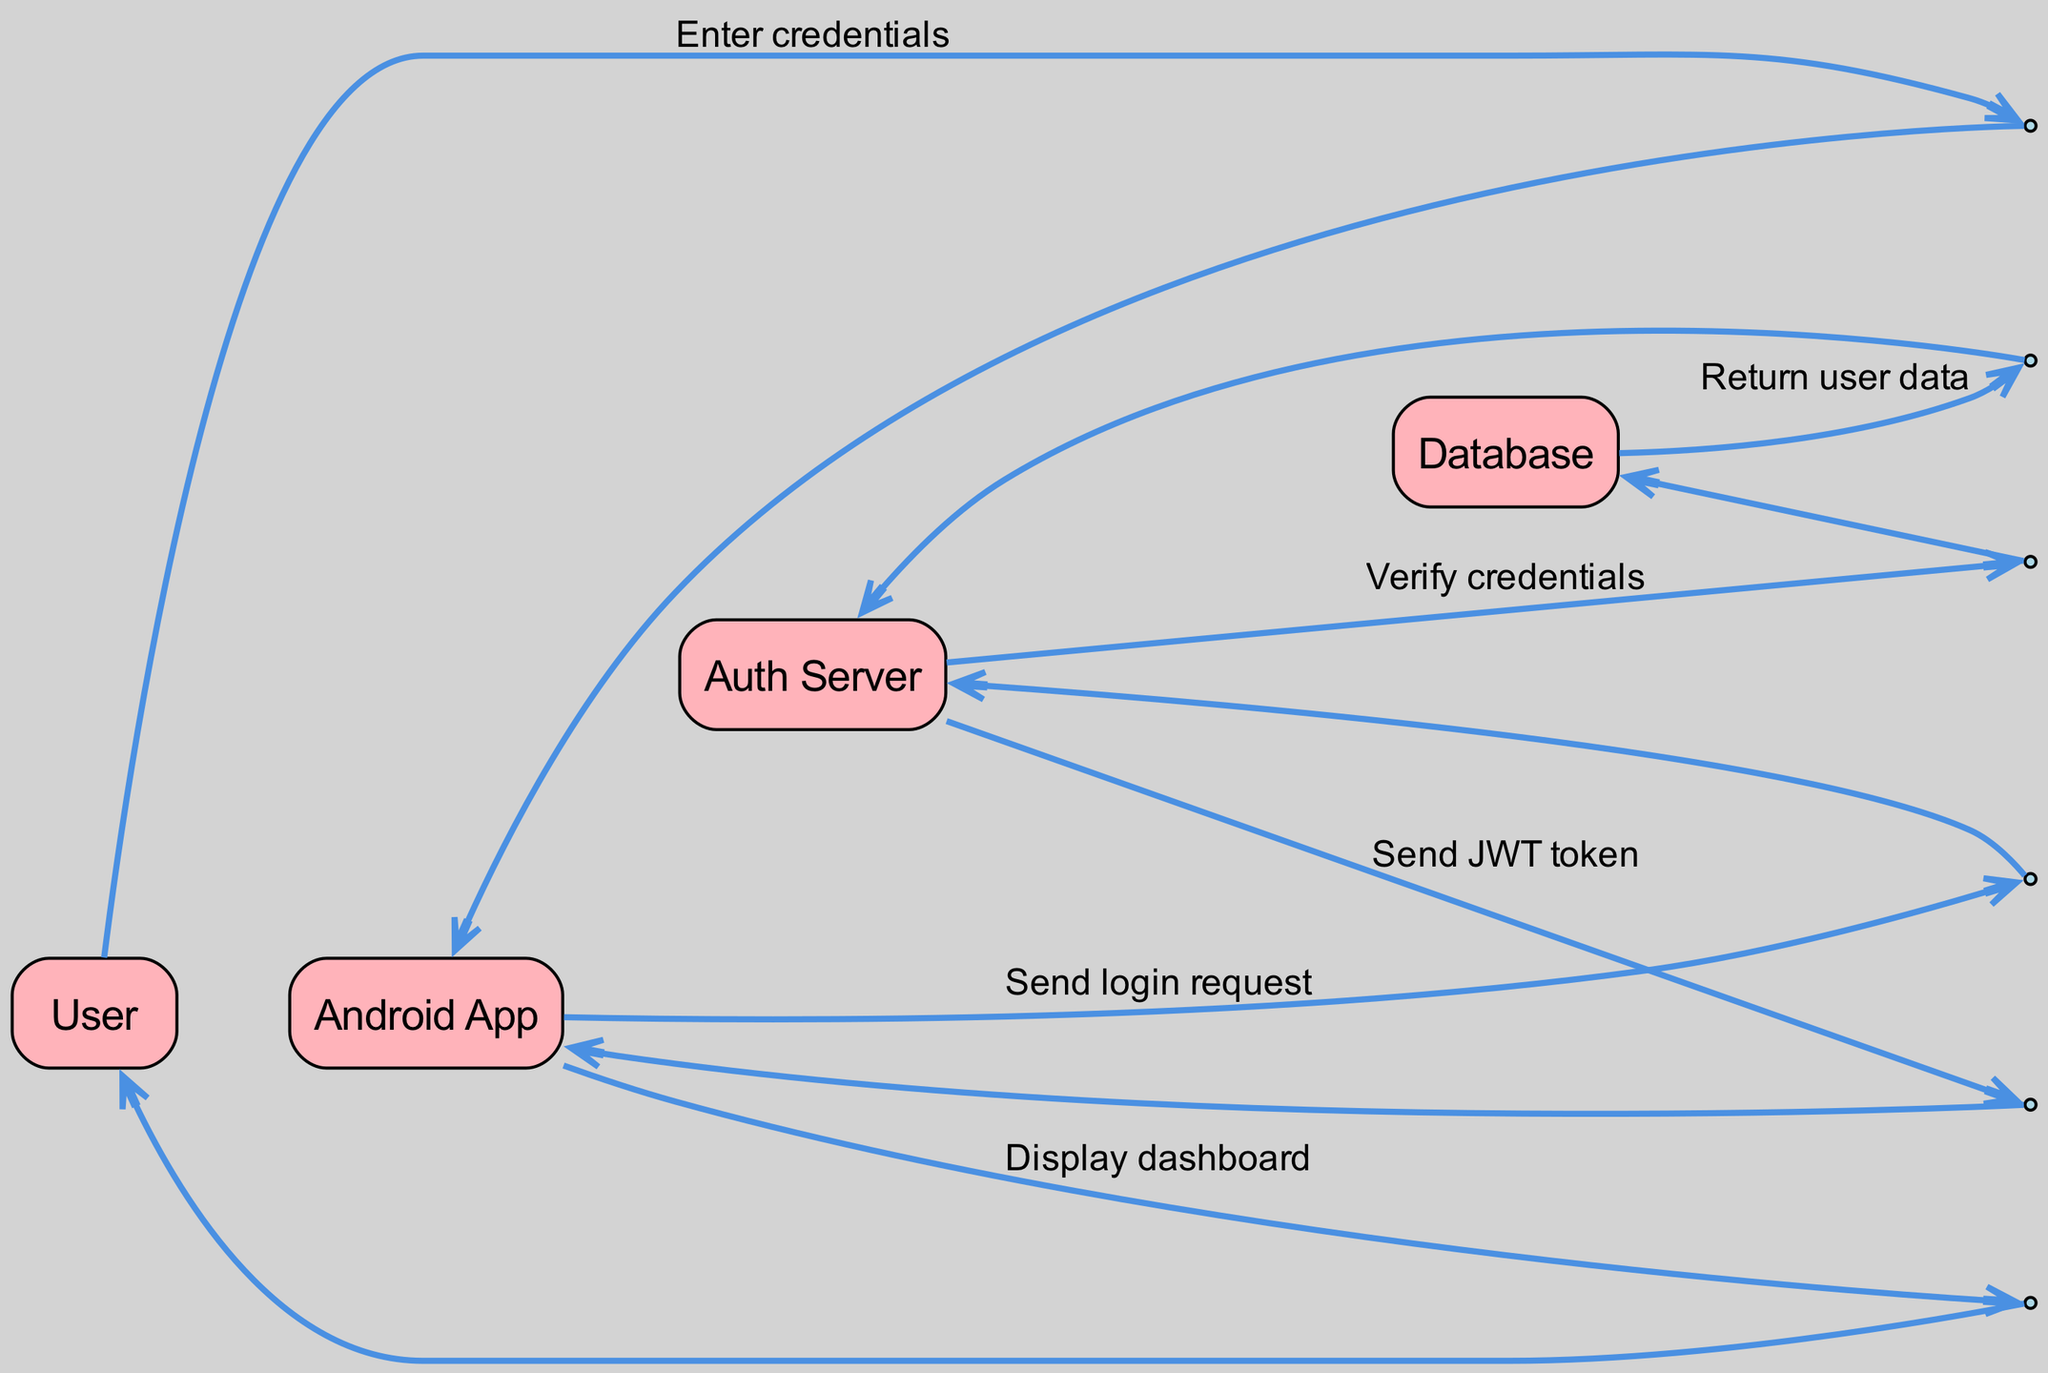What is the first action taken by the User? The first action in the diagram shows the User entering their credentials, which initiates the authentication process.
Answer: Enter credentials How many actors are involved in this diagram? By counting the different entities depicted in the diagram, we see there are four distinct actors: User, Android App, Auth Server, and Database.
Answer: Four What message is sent from the Android App to the Auth Server? The diagram indicates that the message "Send login request" is sent from the Android App to the Auth Server after the User provides their credentials.
Answer: Send login request Which actor verifies the credentials? The diagram shows that the Auth Server communicates with the Database to verify the credentials of the User.
Answer: Auth Server What is the final action taken by the Android App? The final step in the sequence shows the Android App displaying the dashboard to the User after receiving the JWT token from the Auth Server.
Answer: Display dashboard What does the Auth Server return to the Android App after verifying credentials? The Auth Server sends a JWT token to the Android App as a response after verifying the User's credentials with the Database.
Answer: JWT token How many steps are there in the sequence of actions? By counting each step in the sequence from User entering credentials to Android App displaying the dashboard, we find there are six distinct steps in this authentication flow.
Answer: Six What type of message is sent by the Database to the Auth Server? The message sent by the Database to the Auth Server is labeled as "Return user data," indicating a response containing the necessary user information.
Answer: Return user data What are the actors involved in the authentication process? The actors depicted in the diagram as involved in the authentication process are User, Android App, Auth Server, and Database.
Answer: User, Android App, Auth Server, Database 